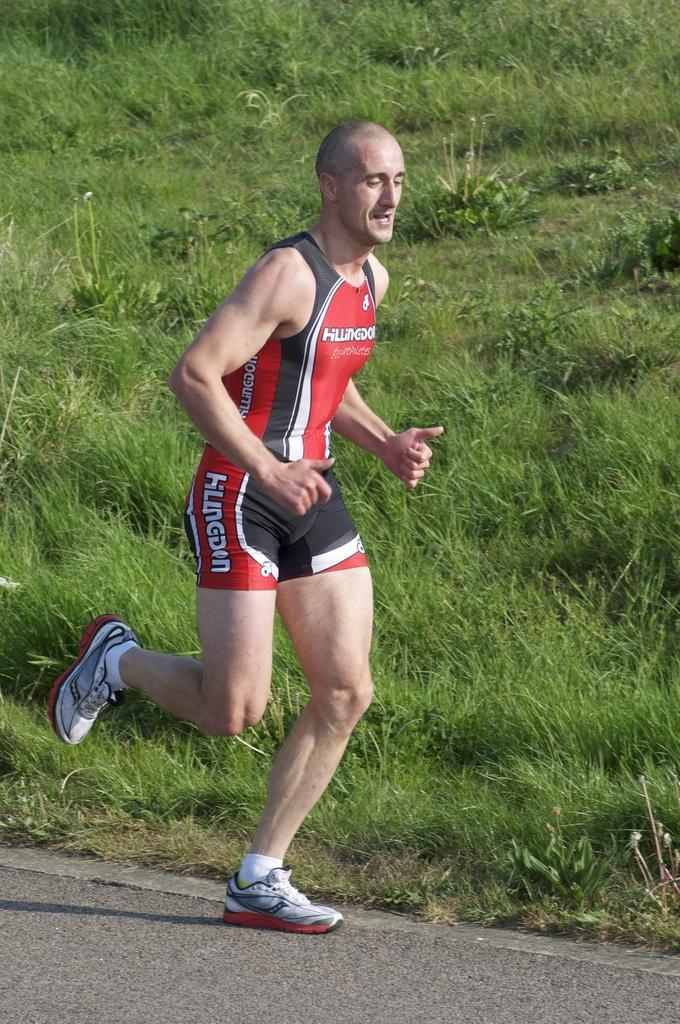<image>
Render a clear and concise summary of the photo. A runner is running in a HLLINOGDON shirt and shorts. 